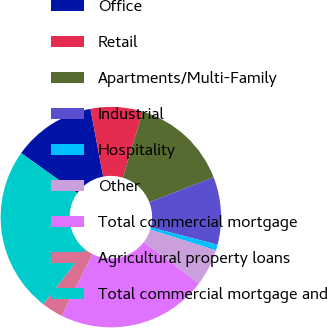Convert chart to OTSL. <chart><loc_0><loc_0><loc_500><loc_500><pie_chart><fcel>Office<fcel>Retail<fcel>Apartments/Multi-Family<fcel>Industrial<fcel>Hospitality<fcel>Other<fcel>Total commercial mortgage<fcel>Agricultural property loans<fcel>Total commercial mortgage and<nl><fcel>12.17%<fcel>7.65%<fcel>14.43%<fcel>9.91%<fcel>0.87%<fcel>5.39%<fcel>22.1%<fcel>3.13%<fcel>24.36%<nl></chart> 